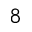<formula> <loc_0><loc_0><loc_500><loc_500>\AA ^ { 8 }</formula> 